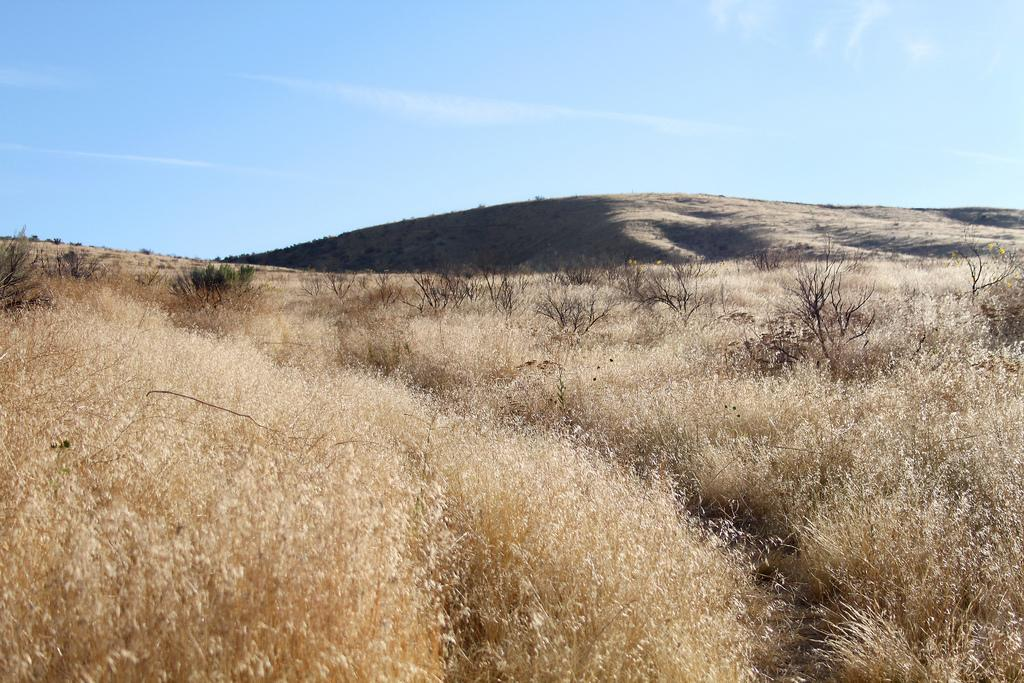What type of vegetation can be seen in the image? There is dried grass in the image. Where are the plants located in the image? The plants are on the hills in the image. What is visible at the top of the image? The sky is visible at the top of the image. Can you see a zipper on any of the plants in the image? There is no zipper present on any of the plants in the image. Is there a zebra grazing on the dried grass in the image? There is no zebra present in the image; it only features plants and dried grass. 